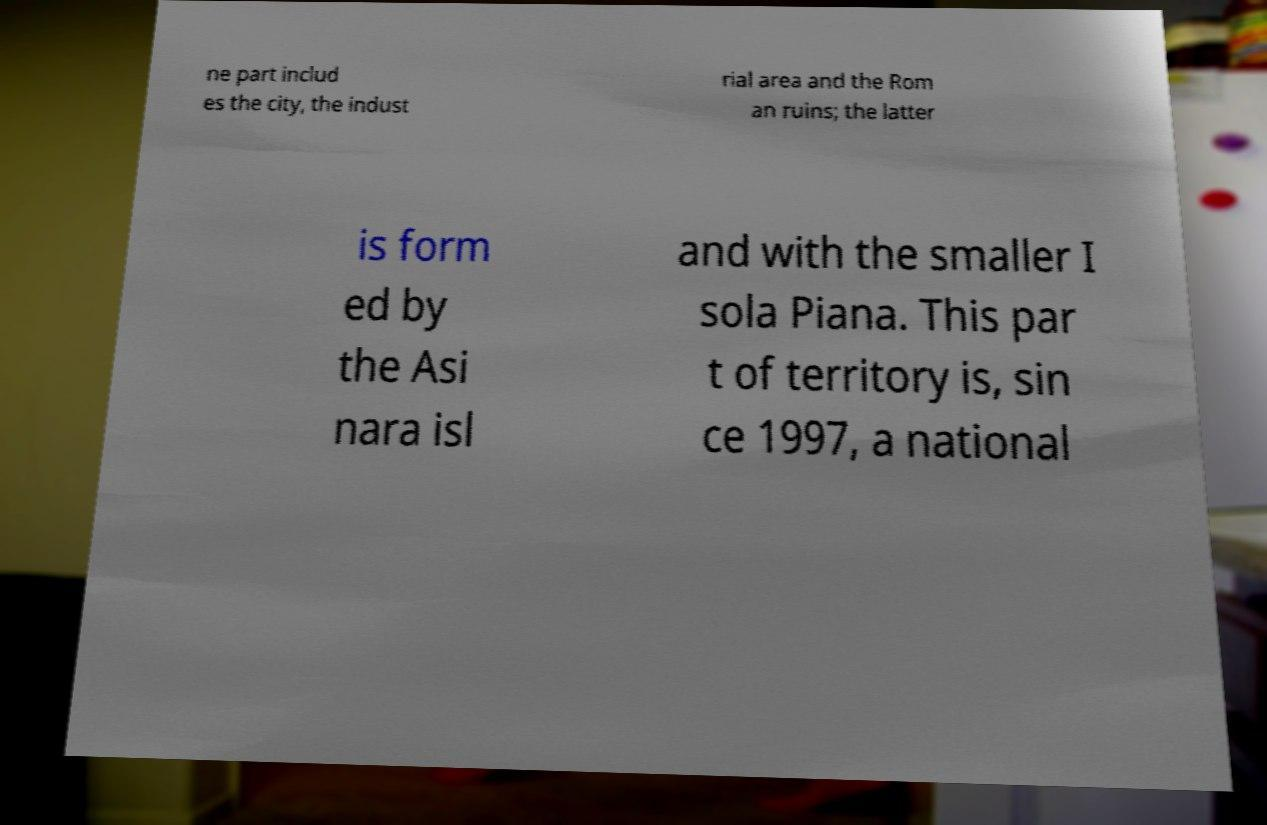Could you assist in decoding the text presented in this image and type it out clearly? ne part includ es the city, the indust rial area and the Rom an ruins; the latter is form ed by the Asi nara isl and with the smaller I sola Piana. This par t of territory is, sin ce 1997, a national 